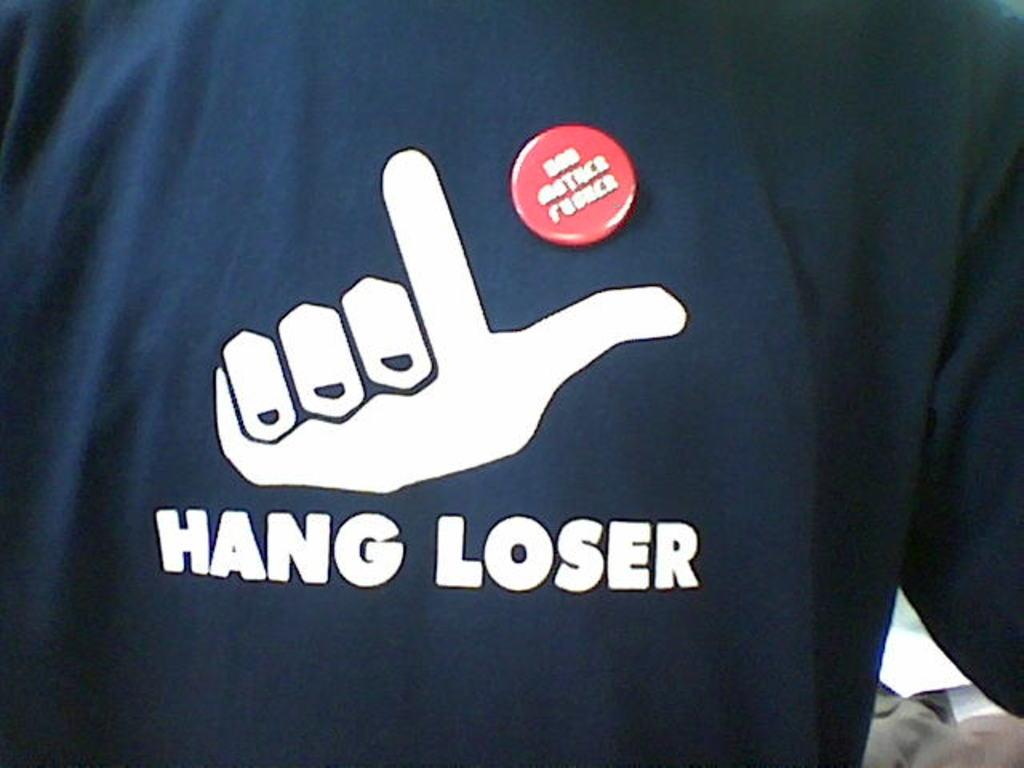What type of clothing item is in the image? There is a t-shirt in the image. What is featured on the t-shirt? There is a symbol on the t-shirt. Can you describe the symbol on the t-shirt? The symbol is described as text. What caption is written below the t-shirt in the image? There is no caption written below the t-shirt in the image. How does the mother in the image relate to the t-shirt? There is no mother present in the image, so it is not possible to determine any relationship between her and the t-shirt. 